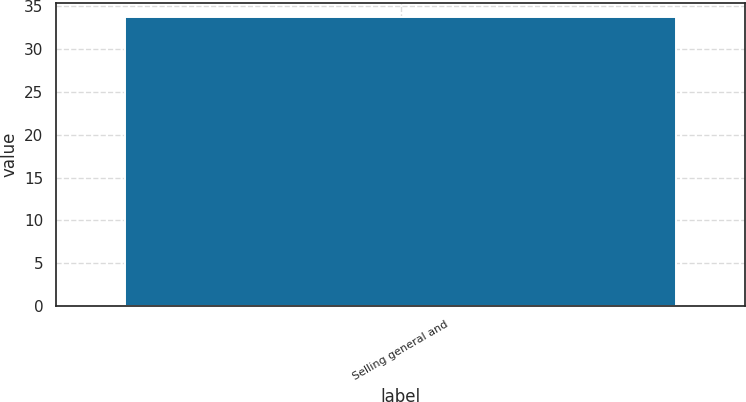Convert chart. <chart><loc_0><loc_0><loc_500><loc_500><bar_chart><fcel>Selling general and<nl><fcel>33.7<nl></chart> 